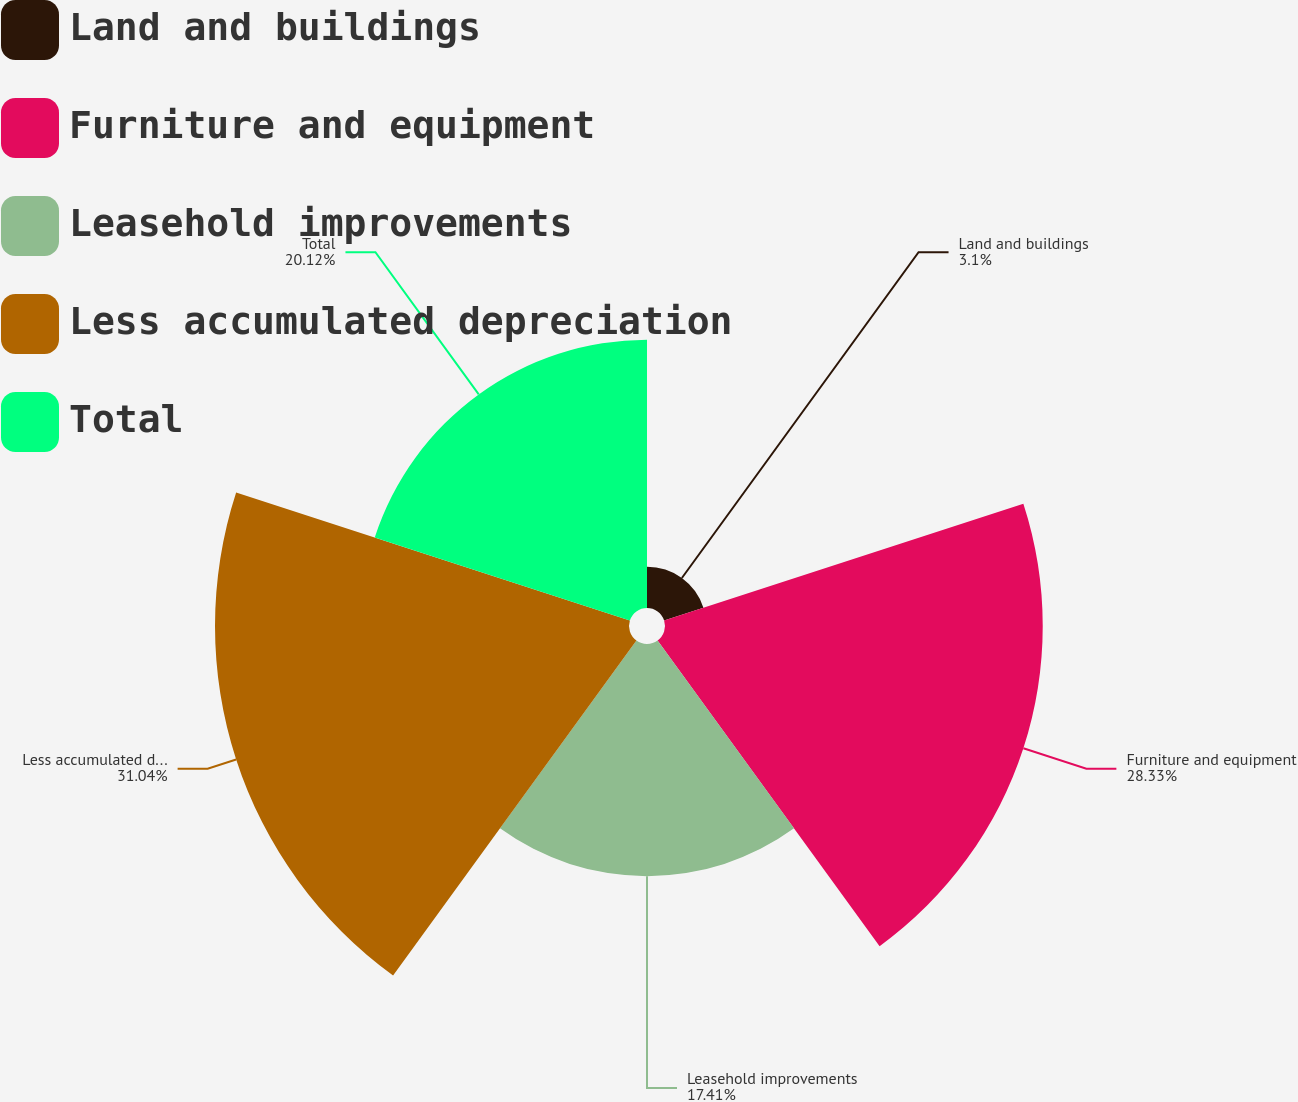<chart> <loc_0><loc_0><loc_500><loc_500><pie_chart><fcel>Land and buildings<fcel>Furniture and equipment<fcel>Leasehold improvements<fcel>Less accumulated depreciation<fcel>Total<nl><fcel>3.1%<fcel>28.33%<fcel>17.41%<fcel>31.05%<fcel>20.12%<nl></chart> 